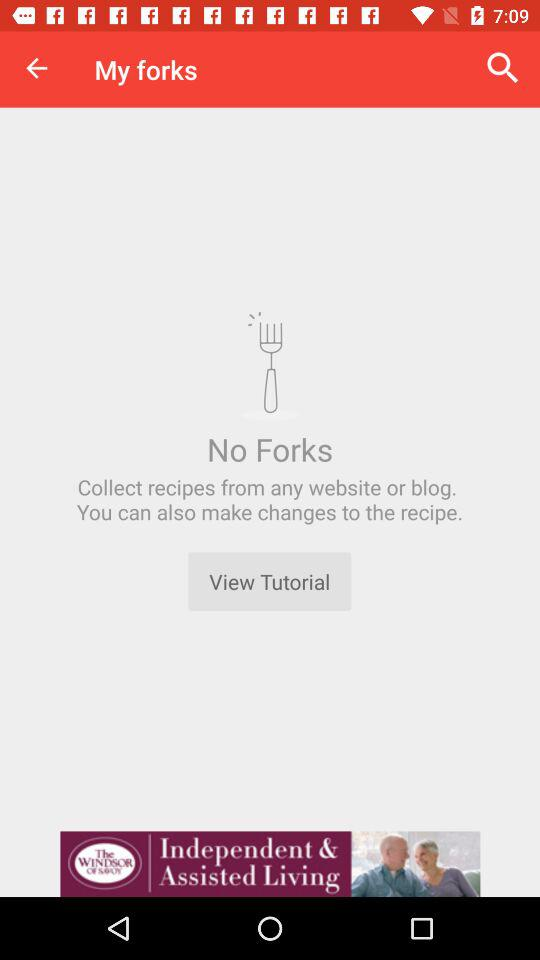How many forks are there? There are no forks. 